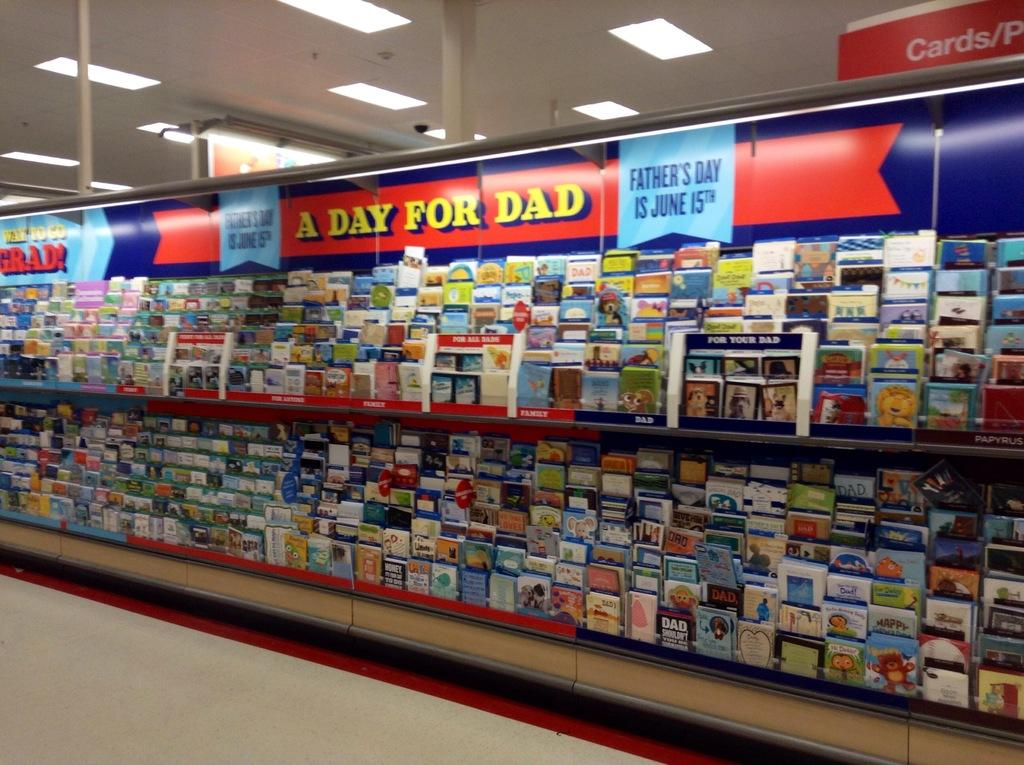<image>
Relay a brief, clear account of the picture shown. A section for cards that is promoting Fathers day. 